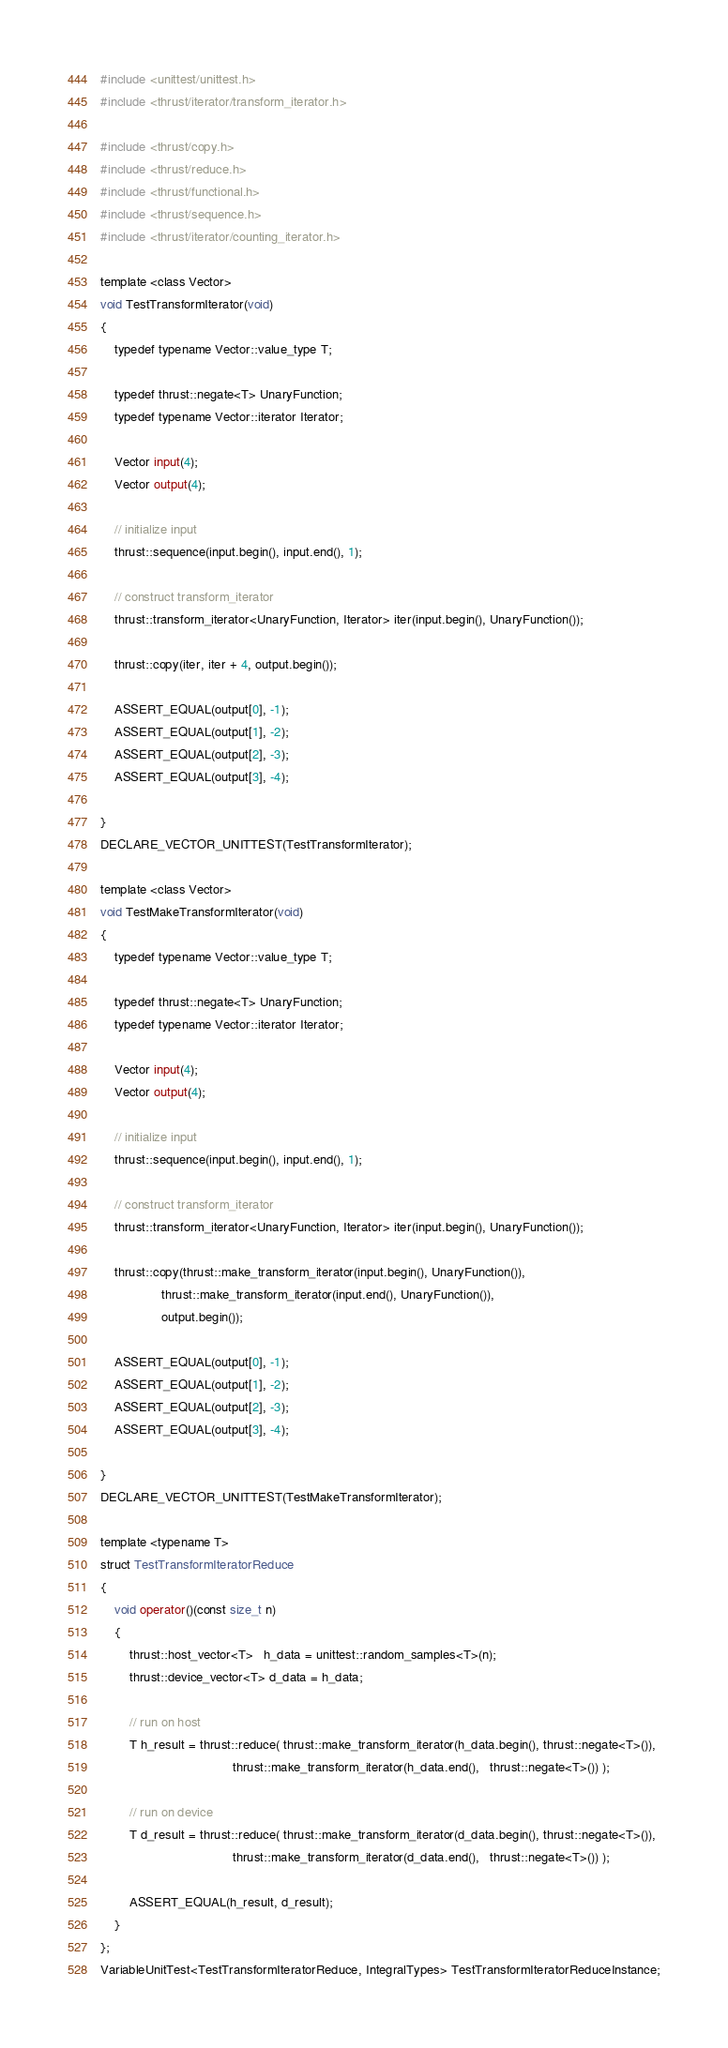Convert code to text. <code><loc_0><loc_0><loc_500><loc_500><_Cuda_>#include <unittest/unittest.h>
#include <thrust/iterator/transform_iterator.h>

#include <thrust/copy.h>
#include <thrust/reduce.h>
#include <thrust/functional.h>
#include <thrust/sequence.h>
#include <thrust/iterator/counting_iterator.h>

template <class Vector>
void TestTransformIterator(void)
{
    typedef typename Vector::value_type T;

    typedef thrust::negate<T> UnaryFunction;
    typedef typename Vector::iterator Iterator;

    Vector input(4);
    Vector output(4);
    
    // initialize input
    thrust::sequence(input.begin(), input.end(), 1);
   
    // construct transform_iterator
    thrust::transform_iterator<UnaryFunction, Iterator> iter(input.begin(), UnaryFunction());

    thrust::copy(iter, iter + 4, output.begin());

    ASSERT_EQUAL(output[0], -1);
    ASSERT_EQUAL(output[1], -2);
    ASSERT_EQUAL(output[2], -3);
    ASSERT_EQUAL(output[3], -4);

}
DECLARE_VECTOR_UNITTEST(TestTransformIterator);

template <class Vector>
void TestMakeTransformIterator(void)
{
    typedef typename Vector::value_type T;

    typedef thrust::negate<T> UnaryFunction;
    typedef typename Vector::iterator Iterator;

    Vector input(4);
    Vector output(4);
    
    // initialize input
    thrust::sequence(input.begin(), input.end(), 1);
   
    // construct transform_iterator
    thrust::transform_iterator<UnaryFunction, Iterator> iter(input.begin(), UnaryFunction());

    thrust::copy(thrust::make_transform_iterator(input.begin(), UnaryFunction()), 
                 thrust::make_transform_iterator(input.end(), UnaryFunction()), 
                 output.begin());

    ASSERT_EQUAL(output[0], -1);
    ASSERT_EQUAL(output[1], -2);
    ASSERT_EQUAL(output[2], -3);
    ASSERT_EQUAL(output[3], -4);

}
DECLARE_VECTOR_UNITTEST(TestMakeTransformIterator);

template <typename T>
struct TestTransformIteratorReduce
{
    void operator()(const size_t n)
    {
        thrust::host_vector<T>   h_data = unittest::random_samples<T>(n);
        thrust::device_vector<T> d_data = h_data;

        // run on host
        T h_result = thrust::reduce( thrust::make_transform_iterator(h_data.begin(), thrust::negate<T>()),
                                     thrust::make_transform_iterator(h_data.end(),   thrust::negate<T>()) );

        // run on device
        T d_result = thrust::reduce( thrust::make_transform_iterator(d_data.begin(), thrust::negate<T>()),
                                     thrust::make_transform_iterator(d_data.end(),   thrust::negate<T>()) );

        ASSERT_EQUAL(h_result, d_result);
    }
};
VariableUnitTest<TestTransformIteratorReduce, IntegralTypes> TestTransformIteratorReduceInstance;

</code> 